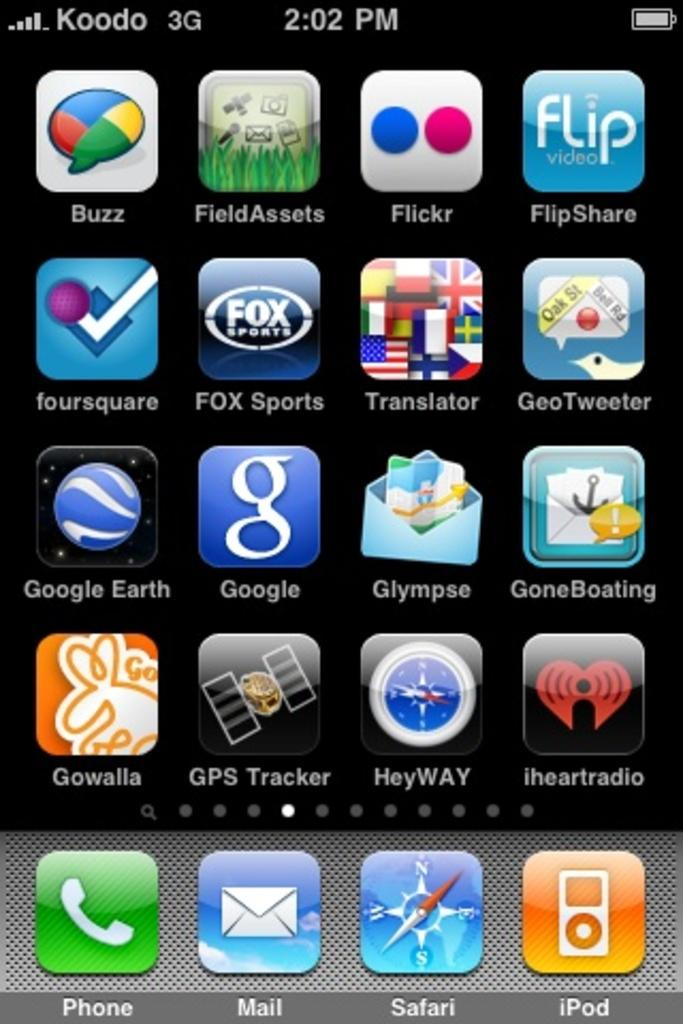What is the main subject of the image? The main subject of the image is a phone screen. What can be seen on the phone screen? There are multiple apps, words, and numbers visible on the phone screen. What is the color of the background on the phone screen? The background of the phone screen is black. Can you see a quill being used to write on the phone screen in the image? No, there is no quill visible in the image, and the phone screen is not being written on with a quill. Is there a badge displayed on the phone screen in the image? No, there is no badge visible on the phone screen in the image. 